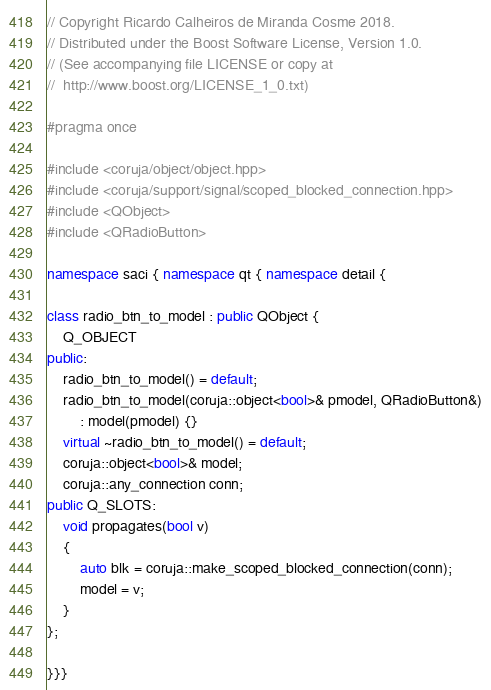Convert code to text. <code><loc_0><loc_0><loc_500><loc_500><_C++_>
// Copyright Ricardo Calheiros de Miranda Cosme 2018.
// Distributed under the Boost Software License, Version 1.0.
// (See accompanying file LICENSE or copy at
//  http://www.boost.org/LICENSE_1_0.txt)

#pragma once

#include <coruja/object/object.hpp>
#include <coruja/support/signal/scoped_blocked_connection.hpp>
#include <QObject>
#include <QRadioButton>

namespace saci { namespace qt { namespace detail {

class radio_btn_to_model : public QObject {
    Q_OBJECT
public:
    radio_btn_to_model() = default;
    radio_btn_to_model(coruja::object<bool>& pmodel, QRadioButton&)
        : model(pmodel) {}
    virtual ~radio_btn_to_model() = default;
    coruja::object<bool>& model;
    coruja::any_connection conn;
public Q_SLOTS:
    void propagates(bool v)
    {
        auto blk = coruja::make_scoped_blocked_connection(conn);
        model = v;
    }
};

}}}
</code> 